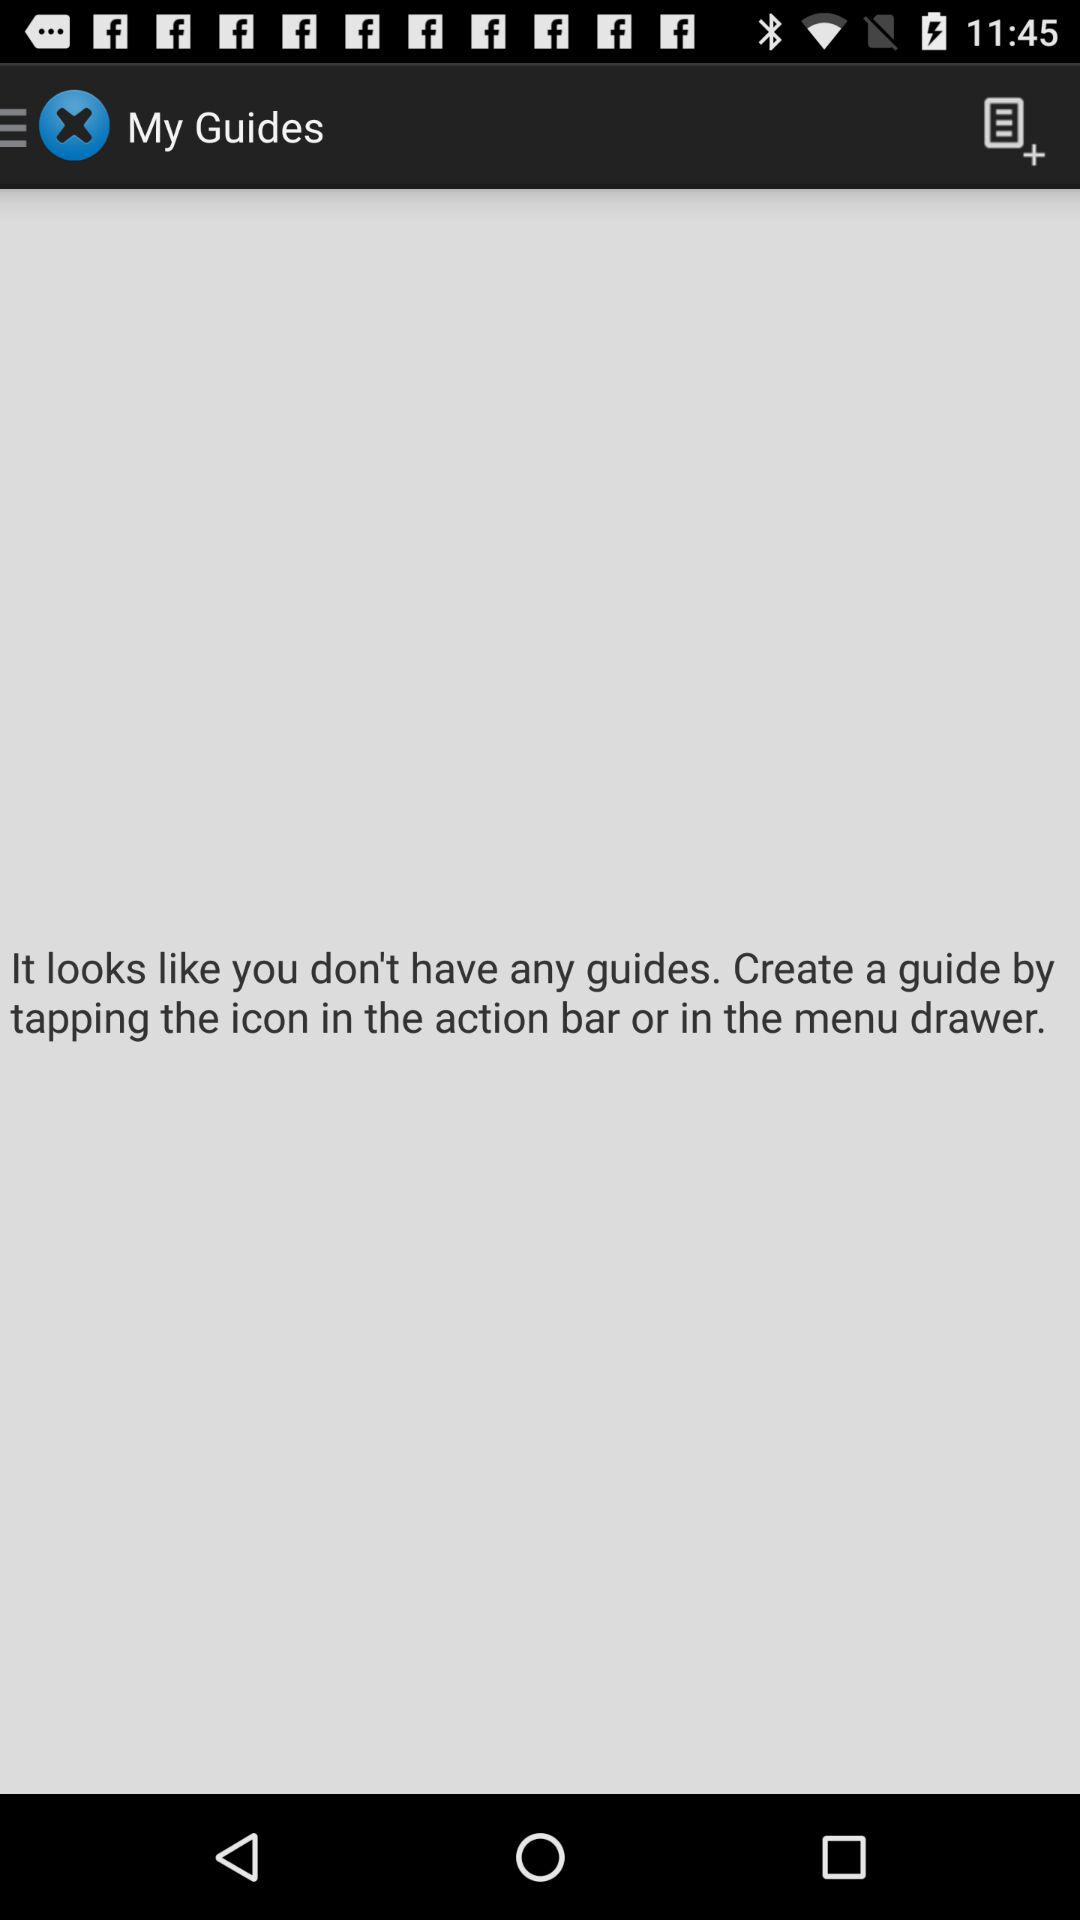How many guides do I have?
Answer the question using a single word or phrase. 0 